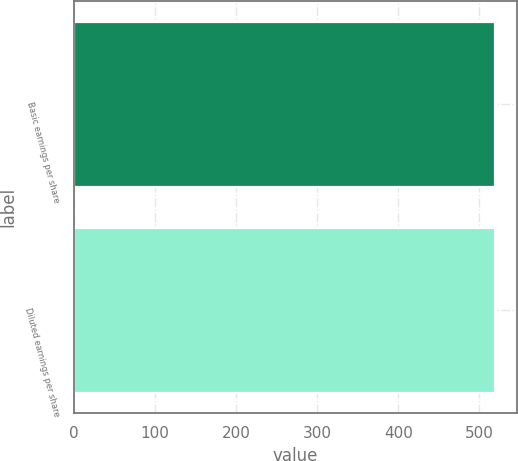<chart> <loc_0><loc_0><loc_500><loc_500><bar_chart><fcel>Basic earnings per share<fcel>Diluted earnings per share<nl><fcel>519.7<fcel>519.8<nl></chart> 